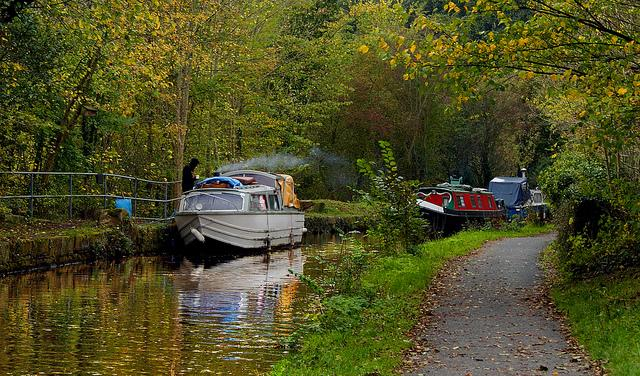What type byway is shown here? river 